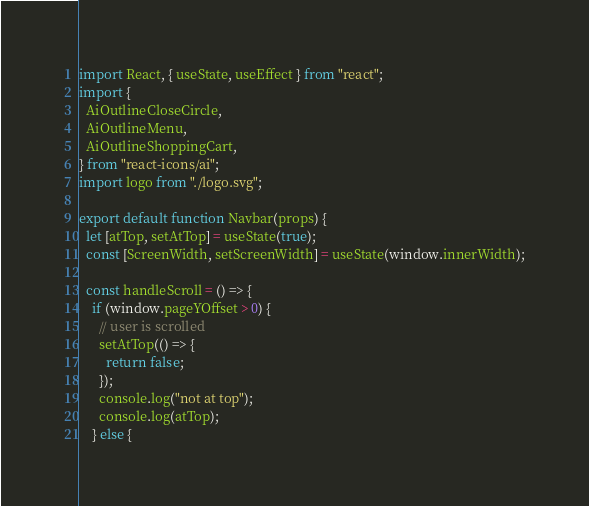Convert code to text. <code><loc_0><loc_0><loc_500><loc_500><_JavaScript_>import React, { useState, useEffect } from "react";
import {
  AiOutlineCloseCircle,
  AiOutlineMenu,
  AiOutlineShoppingCart,
} from "react-icons/ai";
import logo from "./logo.svg";

export default function Navbar(props) {
  let [atTop, setAtTop] = useState(true);
  const [ScreenWidth, setScreenWidth] = useState(window.innerWidth);

  const handleScroll = () => {
    if (window.pageYOffset > 0) {
      // user is scrolled
      setAtTop(() => {
        return false;
      });
      console.log("not at top");
      console.log(atTop);
    } else {</code> 